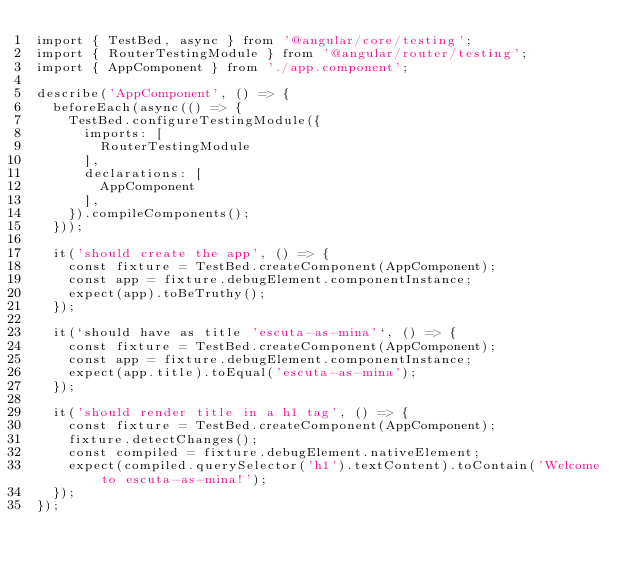<code> <loc_0><loc_0><loc_500><loc_500><_TypeScript_>import { TestBed, async } from '@angular/core/testing';
import { RouterTestingModule } from '@angular/router/testing';
import { AppComponent } from './app.component';

describe('AppComponent', () => {
  beforeEach(async(() => {
    TestBed.configureTestingModule({
      imports: [
        RouterTestingModule
      ],
      declarations: [
        AppComponent
      ],
    }).compileComponents();
  }));

  it('should create the app', () => {
    const fixture = TestBed.createComponent(AppComponent);
    const app = fixture.debugElement.componentInstance;
    expect(app).toBeTruthy();
  });

  it(`should have as title 'escuta-as-mina'`, () => {
    const fixture = TestBed.createComponent(AppComponent);
    const app = fixture.debugElement.componentInstance;
    expect(app.title).toEqual('escuta-as-mina');
  });

  it('should render title in a h1 tag', () => {
    const fixture = TestBed.createComponent(AppComponent);
    fixture.detectChanges();
    const compiled = fixture.debugElement.nativeElement;
    expect(compiled.querySelector('h1').textContent).toContain('Welcome to escuta-as-mina!');
  });
});
</code> 